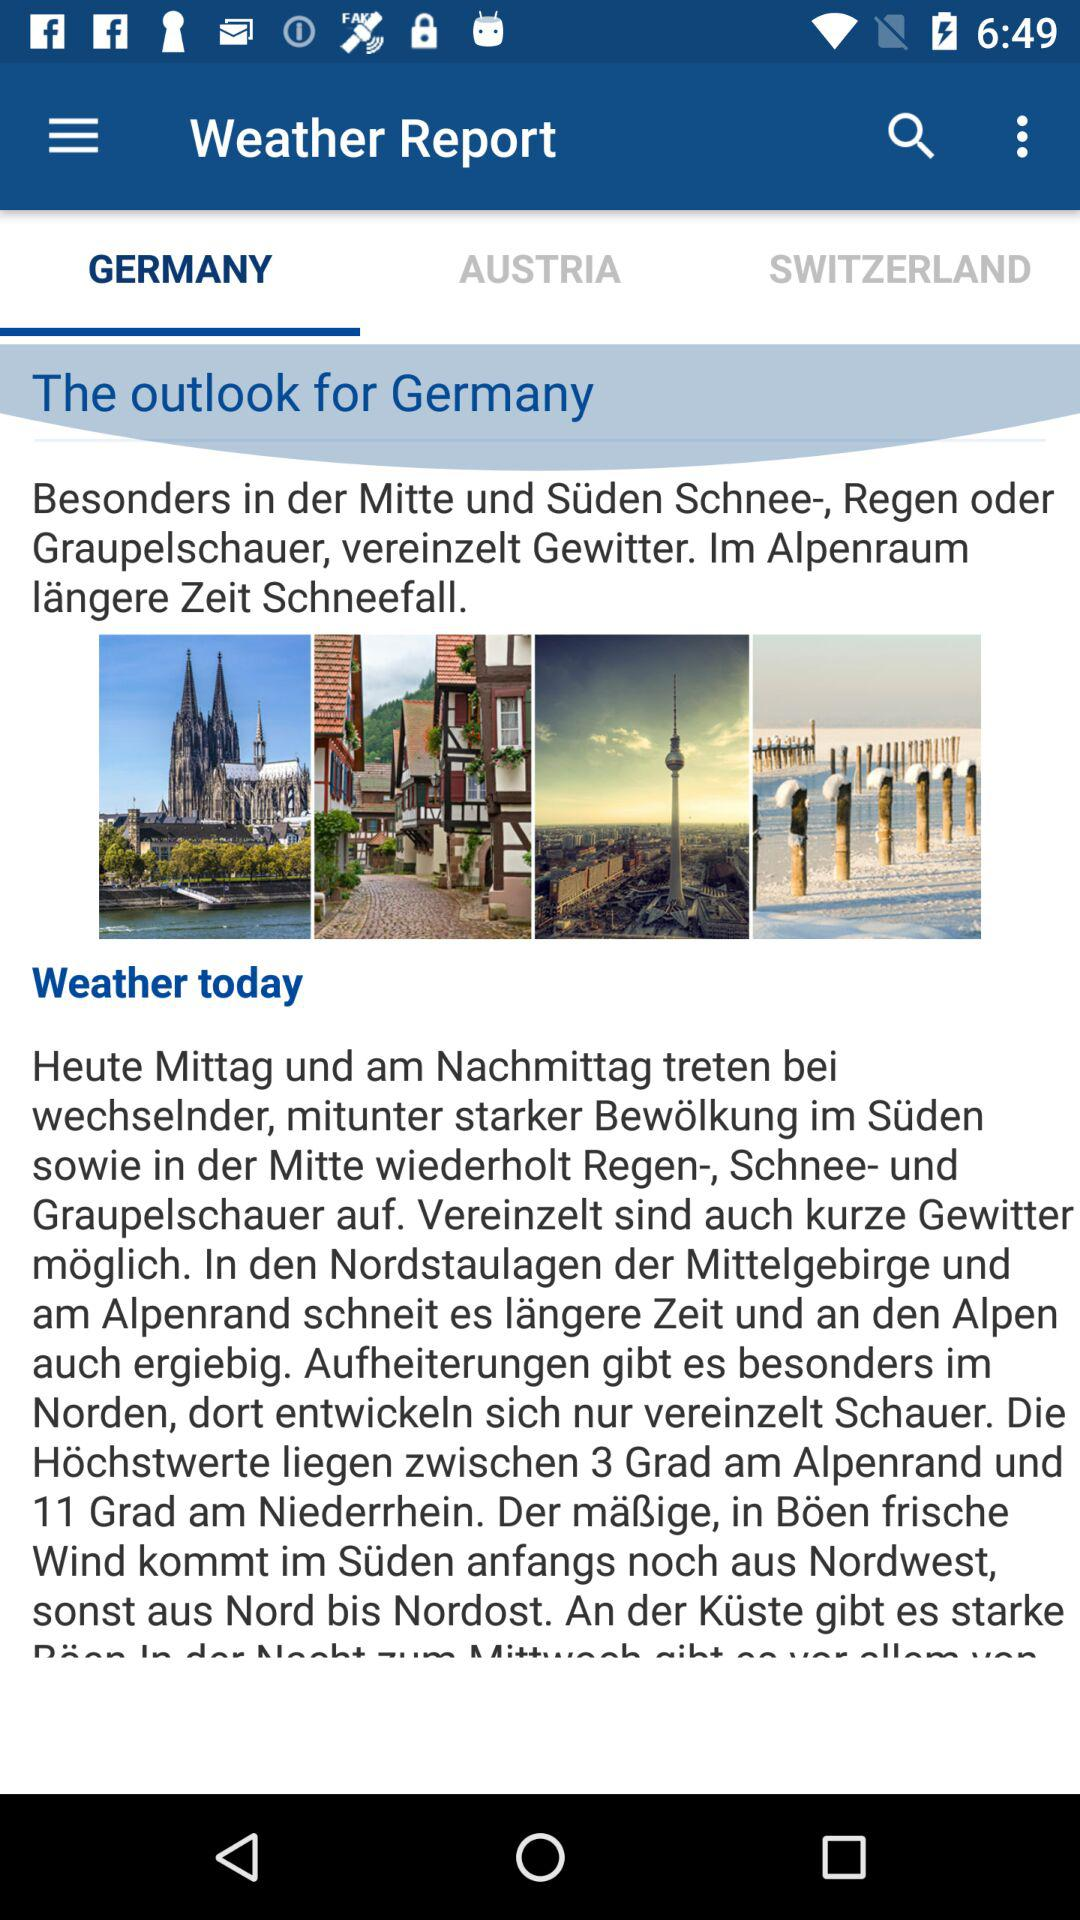Will it rain today in Austria?
When the provided information is insufficient, respond with <no answer>. <no answer> 